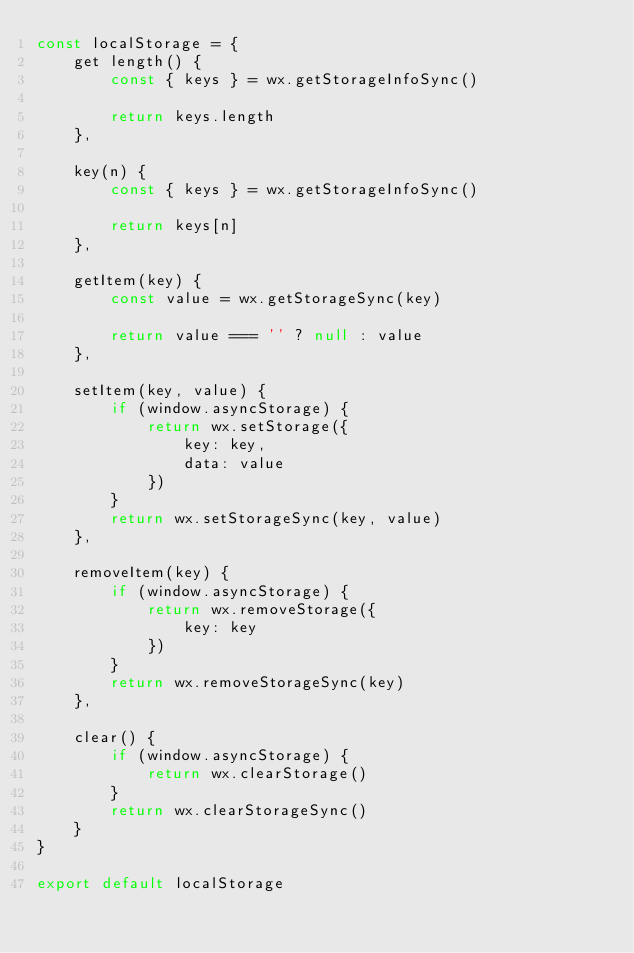Convert code to text. <code><loc_0><loc_0><loc_500><loc_500><_JavaScript_>const localStorage = {
    get length() {
        const { keys } = wx.getStorageInfoSync()

        return keys.length
    },

    key(n) {
        const { keys } = wx.getStorageInfoSync()

        return keys[n]
    },

    getItem(key) {
        const value = wx.getStorageSync(key)

        return value === '' ? null : value
    },

    setItem(key, value) {
        if (window.asyncStorage) {
            return wx.setStorage({
                key: key,
                data: value
            })
        }
        return wx.setStorageSync(key, value)
    },

    removeItem(key) {
        if (window.asyncStorage) {
            return wx.removeStorage({
                key: key
            })
        }
        return wx.removeStorageSync(key)
    },

    clear() {
        if (window.asyncStorage) {
            return wx.clearStorage()
        }
        return wx.clearStorageSync()
    }
}

export default localStorage
</code> 